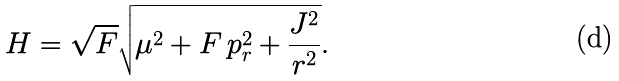Convert formula to latex. <formula><loc_0><loc_0><loc_500><loc_500>H = \sqrt { F } \sqrt { \mu ^ { 2 } + F \, p _ { r } ^ { 2 } + \frac { J ^ { 2 } } { r ^ { 2 } } } .</formula> 